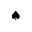Convert formula to latex. <formula><loc_0><loc_0><loc_500><loc_500>^ { a } d e s u i t</formula> 